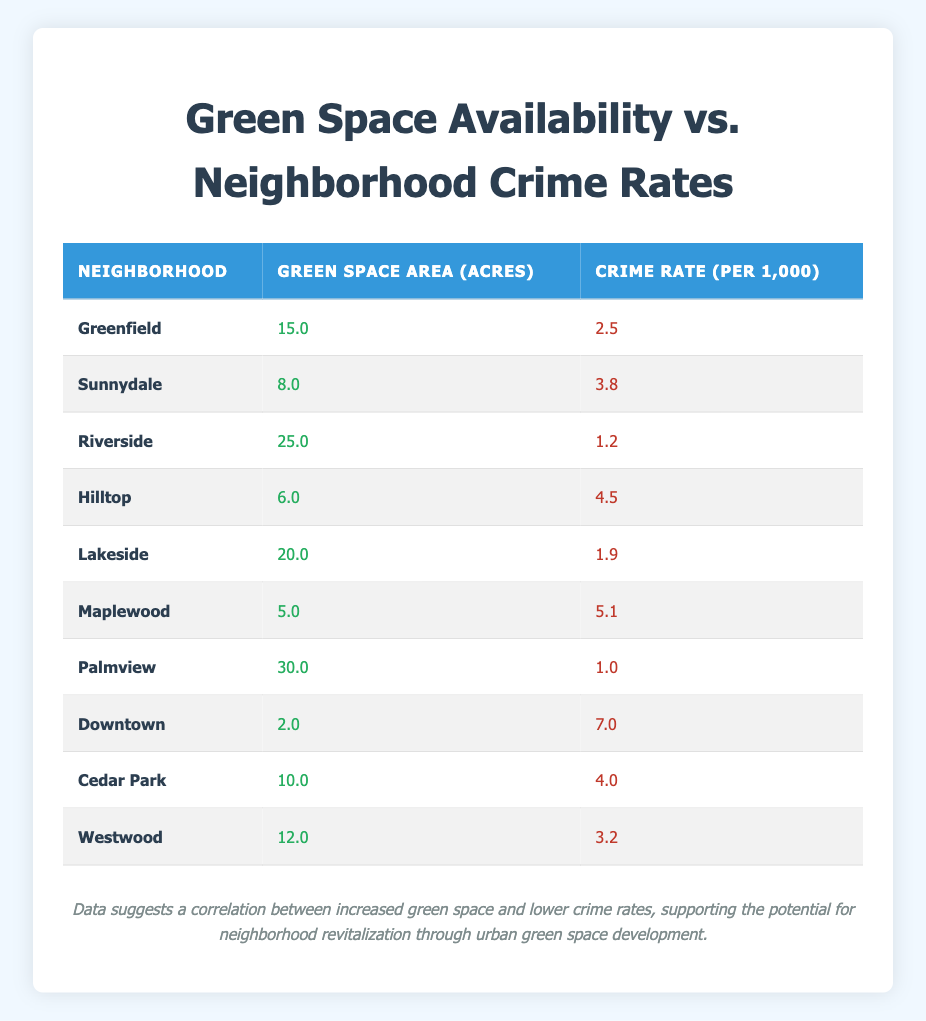What is the neighborhood with the highest crime rate? By looking at the "Crime Rate (per 1,000)" column, I can see that Downtown has the highest value of 7.0.
Answer: Downtown Which neighborhood has the least green space available? The "Green Space Area (Acres)" column shows that Downtown has the least amount of green space with only 2.0 acres.
Answer: Downtown What is the average crime rate for neighborhoods with more than 15 acres of green space? The neighborhoods with more than 15 acres are Greenfield (2.5), Riverside (1.2), Lakeside (1.9), and Palmview (1.0). Adding these up gives 2.5 + 1.2 + 1.9 + 1.0 = 6.6. There are 4 neighborhoods, so the average is 6.6 / 4 = 1.65.
Answer: 1.65 Is it true that all neighborhoods with more than 20 acres of green space have a crime rate below 3.0? The only neighborhoods with more than 20 acres are Riverside (1.2), Lakeside (1.9), and Palmview (1.0). All three have crime rates below 3.0, confirming the statement as true.
Answer: True What is the difference in crime rates between the neighborhood with the most green space and the neighborhood with the least? Palmview has the most green space with 30.0 acres and a crime rate of 1.0, while Downtown has the least green space with 2.0 acres and a crime rate of 7.0. The difference is 7.0 - 1.0 = 6.0.
Answer: 6.0 How many neighborhoods have a crime rate above 4.0? By counting the crime rates in the table: Hilltop (4.5), Maplewood (5.1), and Downtown (7.0) are above 4.0. This totals to 3 neighborhoods.
Answer: 3 What is the total green space area across all neighborhoods? Summing the green space areas: 15.0 + 8.0 + 25.0 + 6.0 + 20.0 + 5.0 + 30.0 + 2.0 + 10.0 + 12.0 = 133.0 acres.
Answer: 133.0 Are there any neighborhoods where the crime rate is below 3.0? Yes, checking the table shows that Riverside (1.2), Lakeside (1.9), and Palmview (1.0) all have crime rates below 3.0.
Answer: Yes 